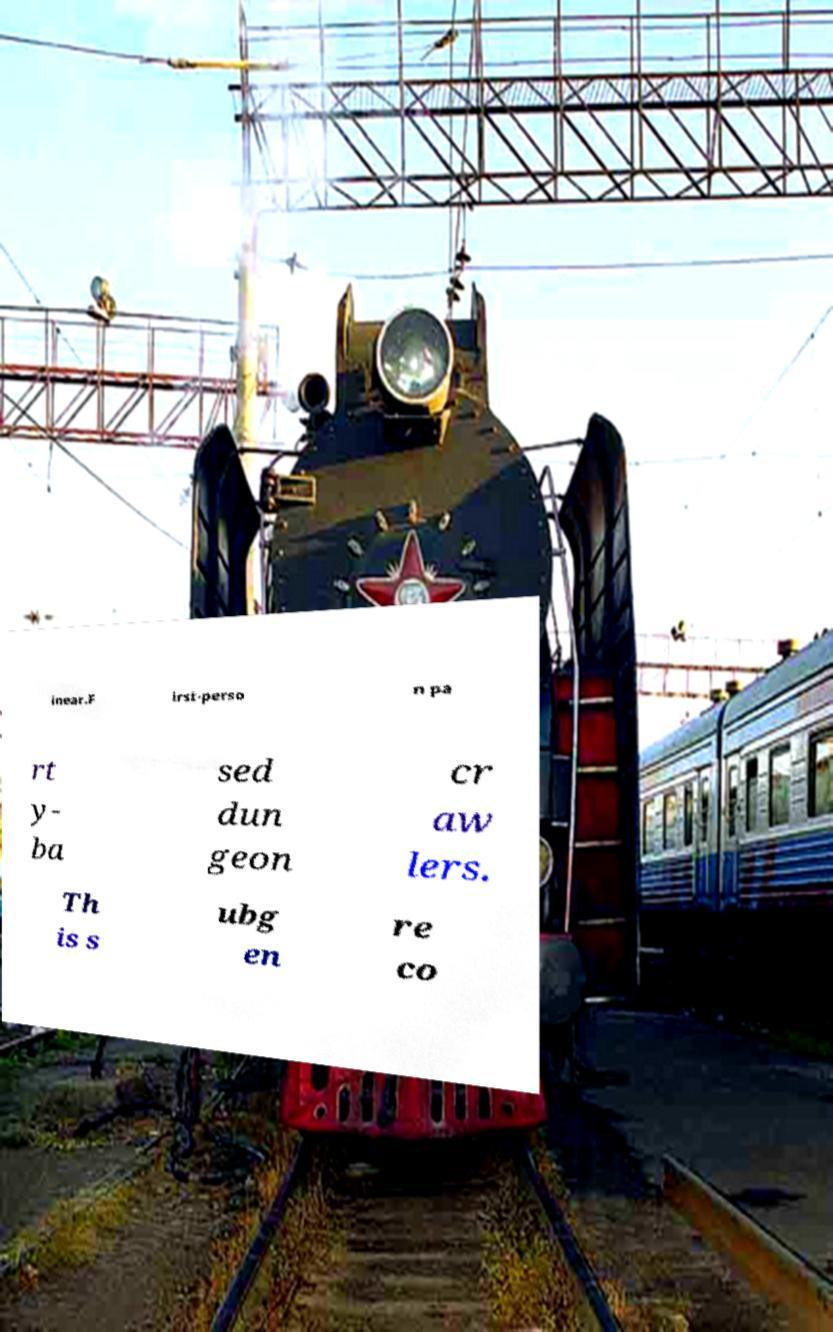There's text embedded in this image that I need extracted. Can you transcribe it verbatim? inear.F irst-perso n pa rt y- ba sed dun geon cr aw lers. Th is s ubg en re co 